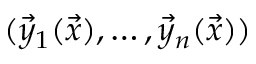Convert formula to latex. <formula><loc_0><loc_0><loc_500><loc_500>( \vec { y } _ { 1 } ( \vec { x } ) , \dots , \vec { y } _ { n } ( \vec { x } ) )</formula> 